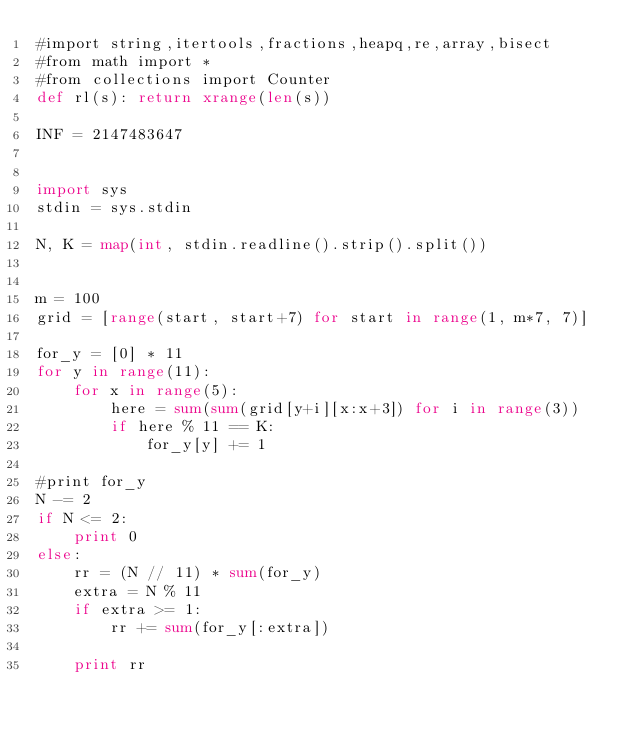<code> <loc_0><loc_0><loc_500><loc_500><_Python_>#import string,itertools,fractions,heapq,re,array,bisect
#from math import *
#from collections import Counter
def rl(s): return xrange(len(s))

INF = 2147483647


import sys
stdin = sys.stdin

N, K = map(int, stdin.readline().strip().split())


m = 100
grid = [range(start, start+7) for start in range(1, m*7, 7)]

for_y = [0] * 11
for y in range(11):
    for x in range(5):
        here = sum(sum(grid[y+i][x:x+3]) for i in range(3))
        if here % 11 == K:
            for_y[y] += 1

#print for_y
N -= 2
if N <= 2:
    print 0
else:
    rr = (N // 11) * sum(for_y)
    extra = N % 11
    if extra >= 1:
        rr += sum(for_y[:extra])

    print rr




</code> 